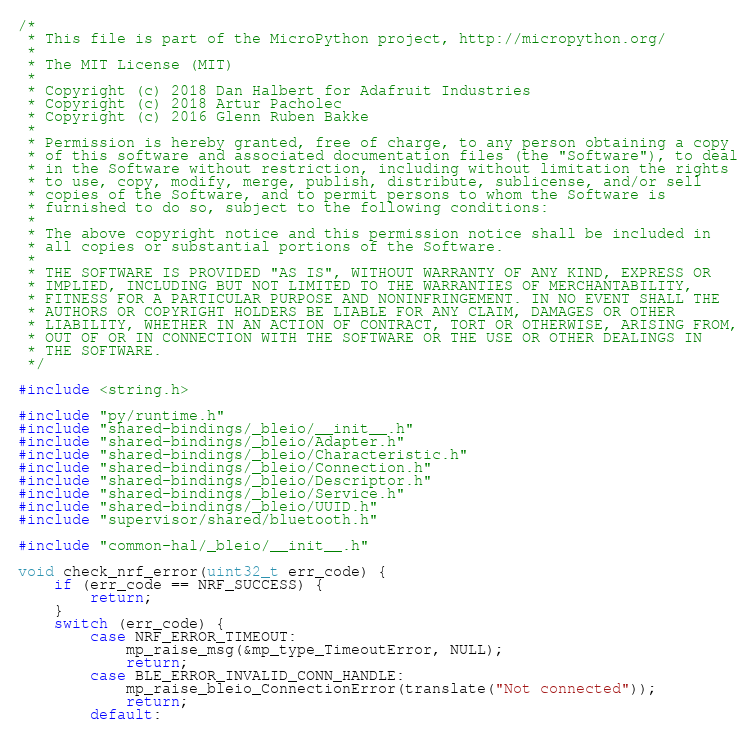Convert code to text. <code><loc_0><loc_0><loc_500><loc_500><_C_>/*
 * This file is part of the MicroPython project, http://micropython.org/
 *
 * The MIT License (MIT)
 *
 * Copyright (c) 2018 Dan Halbert for Adafruit Industries
 * Copyright (c) 2018 Artur Pacholec
 * Copyright (c) 2016 Glenn Ruben Bakke
 *
 * Permission is hereby granted, free of charge, to any person obtaining a copy
 * of this software and associated documentation files (the "Software"), to deal
 * in the Software without restriction, including without limitation the rights
 * to use, copy, modify, merge, publish, distribute, sublicense, and/or sell
 * copies of the Software, and to permit persons to whom the Software is
 * furnished to do so, subject to the following conditions:
 *
 * The above copyright notice and this permission notice shall be included in
 * all copies or substantial portions of the Software.
 *
 * THE SOFTWARE IS PROVIDED "AS IS", WITHOUT WARRANTY OF ANY KIND, EXPRESS OR
 * IMPLIED, INCLUDING BUT NOT LIMITED TO THE WARRANTIES OF MERCHANTABILITY,
 * FITNESS FOR A PARTICULAR PURPOSE AND NONINFRINGEMENT. IN NO EVENT SHALL THE
 * AUTHORS OR COPYRIGHT HOLDERS BE LIABLE FOR ANY CLAIM, DAMAGES OR OTHER
 * LIABILITY, WHETHER IN AN ACTION OF CONTRACT, TORT OR OTHERWISE, ARISING FROM,
 * OUT OF OR IN CONNECTION WITH THE SOFTWARE OR THE USE OR OTHER DEALINGS IN
 * THE SOFTWARE.
 */

#include <string.h>

#include "py/runtime.h"
#include "shared-bindings/_bleio/__init__.h"
#include "shared-bindings/_bleio/Adapter.h"
#include "shared-bindings/_bleio/Characteristic.h"
#include "shared-bindings/_bleio/Connection.h"
#include "shared-bindings/_bleio/Descriptor.h"
#include "shared-bindings/_bleio/Service.h"
#include "shared-bindings/_bleio/UUID.h"
#include "supervisor/shared/bluetooth.h"

#include "common-hal/_bleio/__init__.h"

void check_nrf_error(uint32_t err_code) {
    if (err_code == NRF_SUCCESS) {
        return;
    }
    switch (err_code) {
        case NRF_ERROR_TIMEOUT:
            mp_raise_msg(&mp_type_TimeoutError, NULL);
            return;
        case BLE_ERROR_INVALID_CONN_HANDLE:
            mp_raise_bleio_ConnectionError(translate("Not connected"));
            return;
        default:</code> 